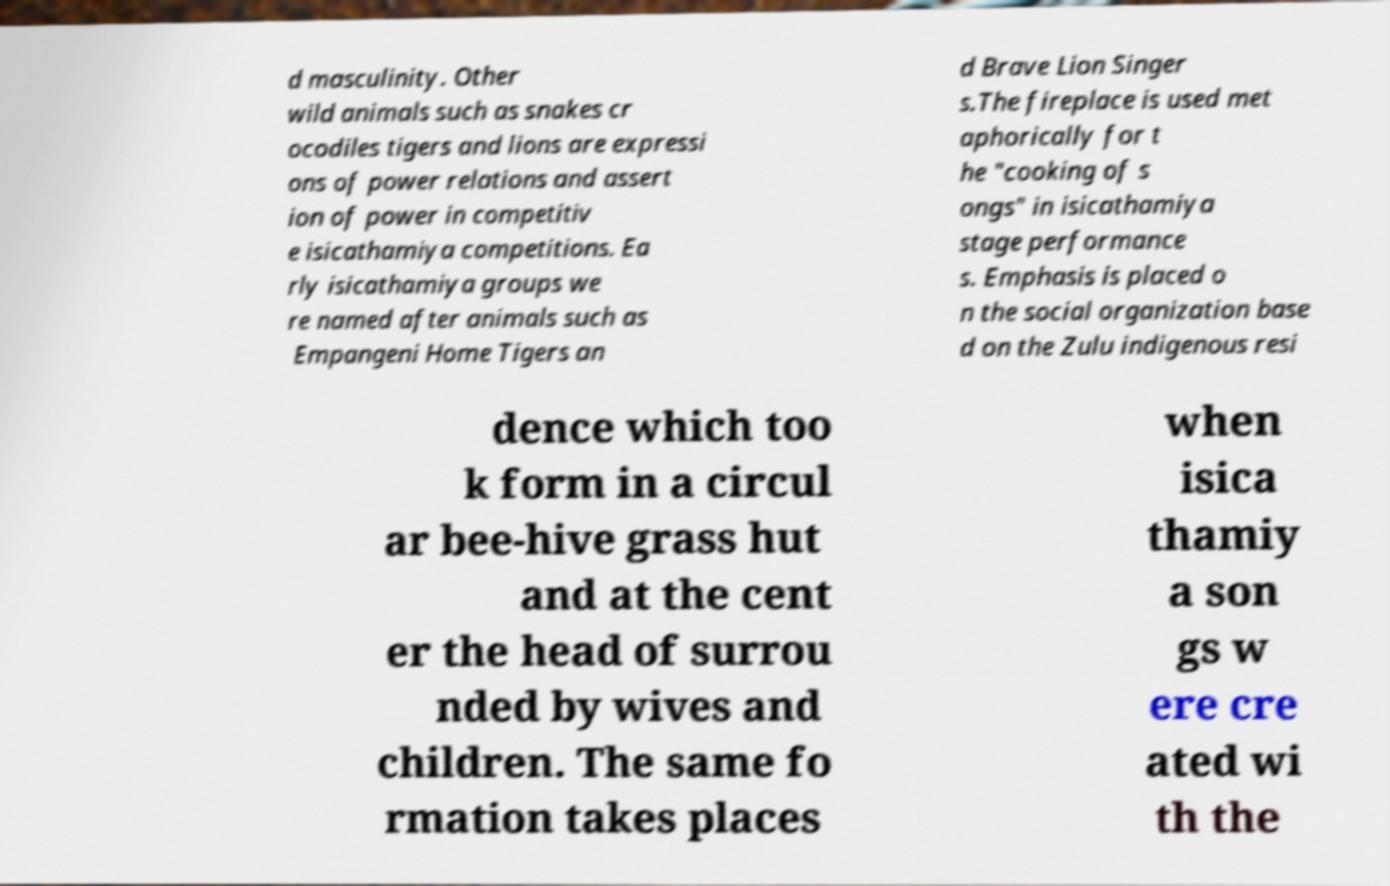Could you extract and type out the text from this image? d masculinity. Other wild animals such as snakes cr ocodiles tigers and lions are expressi ons of power relations and assert ion of power in competitiv e isicathamiya competitions. Ea rly isicathamiya groups we re named after animals such as Empangeni Home Tigers an d Brave Lion Singer s.The fireplace is used met aphorically for t he "cooking of s ongs" in isicathamiya stage performance s. Emphasis is placed o n the social organization base d on the Zulu indigenous resi dence which too k form in a circul ar bee-hive grass hut and at the cent er the head of surrou nded by wives and children. The same fo rmation takes places when isica thamiy a son gs w ere cre ated wi th the 